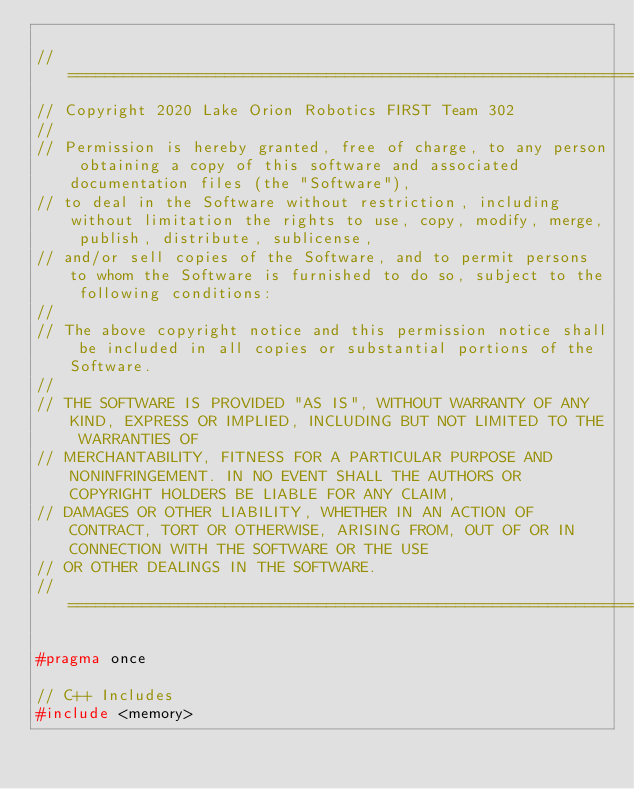Convert code to text. <code><loc_0><loc_0><loc_500><loc_500><_C_>
//====================================================================================================================================================
// Copyright 2020 Lake Orion Robotics FIRST Team 302 
//
// Permission is hereby granted, free of charge, to any person obtaining a copy of this software and associated documentation files (the "Software"),
// to deal in the Software without restriction, including without limitation the rights to use, copy, modify, merge, publish, distribute, sublicense,
// and/or sell copies of the Software, and to permit persons to whom the Software is furnished to do so, subject to the following conditions:
//
// The above copyright notice and this permission notice shall be included in all copies or substantial portions of the Software.
//
// THE SOFTWARE IS PROVIDED "AS IS", WITHOUT WARRANTY OF ANY KIND, EXPRESS OR IMPLIED, INCLUDING BUT NOT LIMITED TO THE WARRANTIES OF
// MERCHANTABILITY, FITNESS FOR A PARTICULAR PURPOSE AND NONINFRINGEMENT. IN NO EVENT SHALL THE AUTHORS OR COPYRIGHT HOLDERS BE LIABLE FOR ANY CLAIM,
// DAMAGES OR OTHER LIABILITY, WHETHER IN AN ACTION OF CONTRACT, TORT OR OTHERWISE, ARISING FROM, OUT OF OR IN CONNECTION WITH THE SOFTWARE OR THE USE
// OR OTHER DEALINGS IN THE SOFTWARE.
//====================================================================================================================================================

#pragma once

// C++ Includes
#include <memory>
</code> 